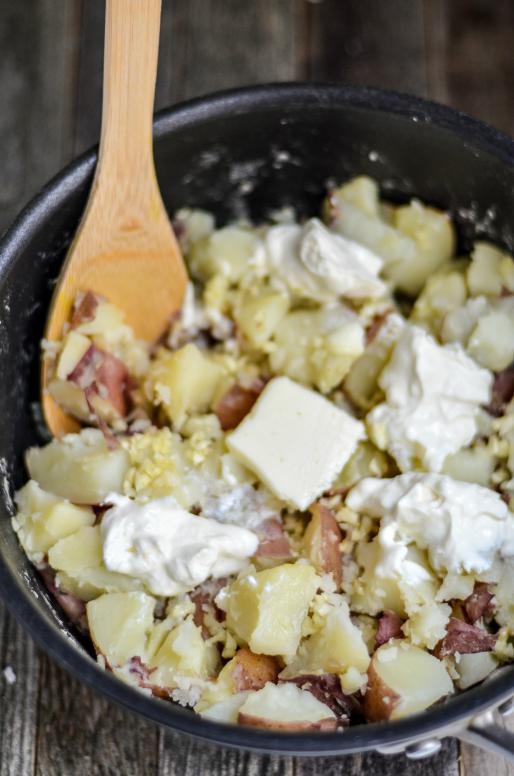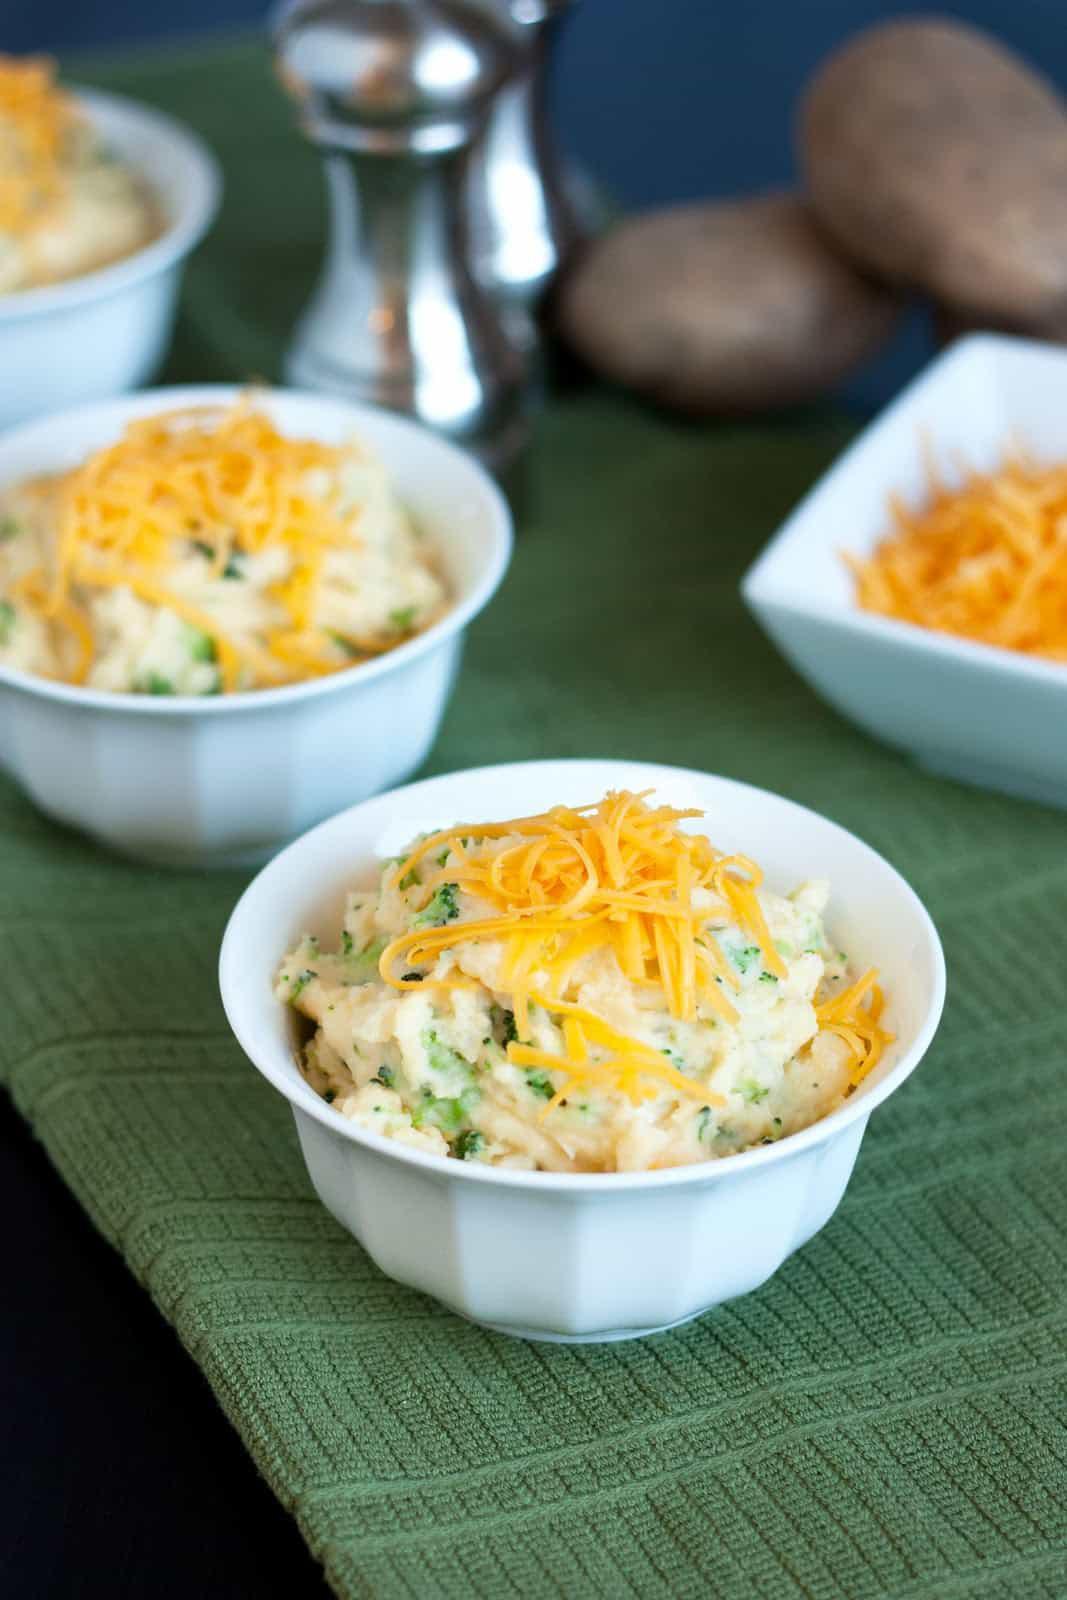The first image is the image on the left, the second image is the image on the right. Assess this claim about the two images: "An image shows a fork resting on a white plate of food.". Correct or not? Answer yes or no. No. The first image is the image on the left, the second image is the image on the right. For the images shown, is this caption "A silver fork is sitting near the food in the image on the right." true? Answer yes or no. No. 